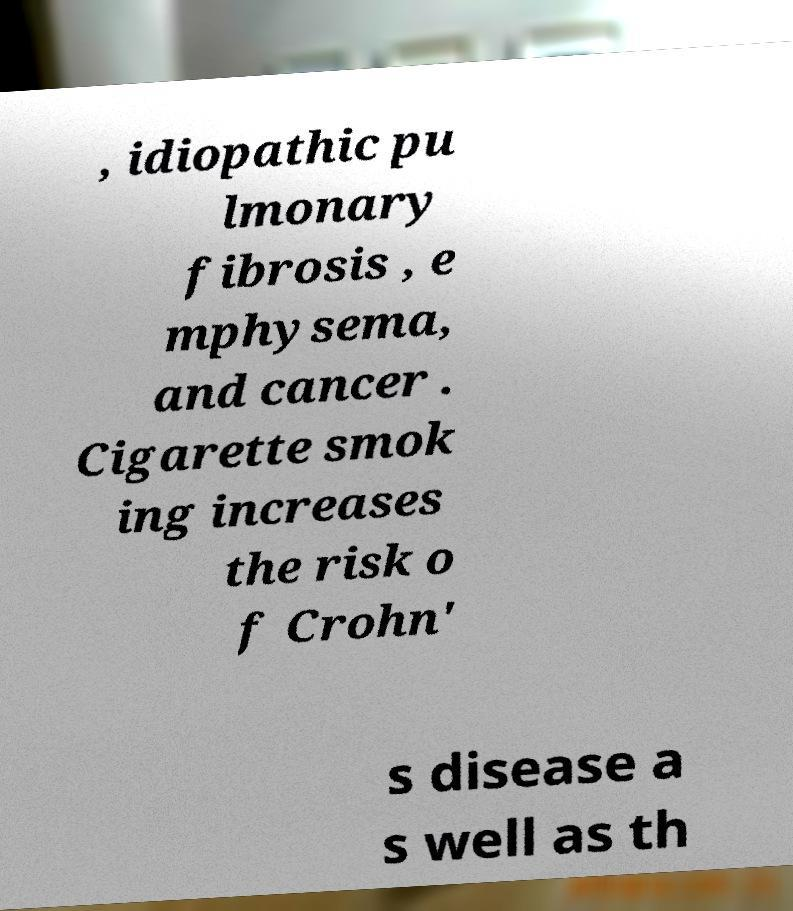Please read and relay the text visible in this image. What does it say? , idiopathic pu lmonary fibrosis , e mphysema, and cancer . Cigarette smok ing increases the risk o f Crohn' s disease a s well as th 